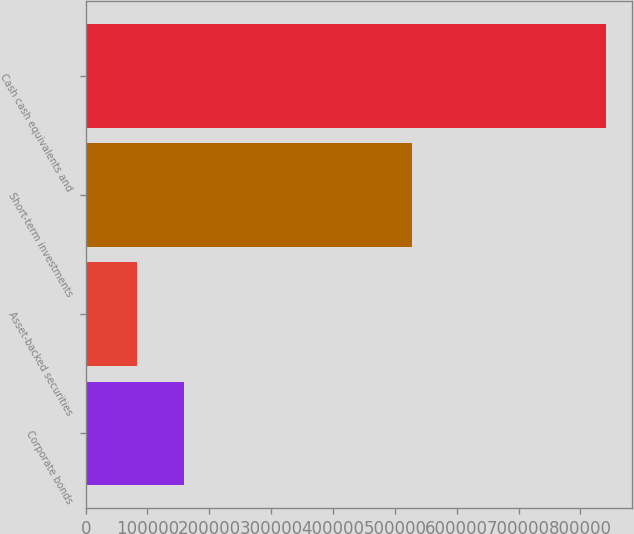<chart> <loc_0><loc_0><loc_500><loc_500><bar_chart><fcel>Corporate bonds<fcel>Asset-backed securities<fcel>Short-term investments<fcel>Cash cash equivalents and<nl><fcel>159311<fcel>83044<fcel>527256<fcel>840864<nl></chart> 